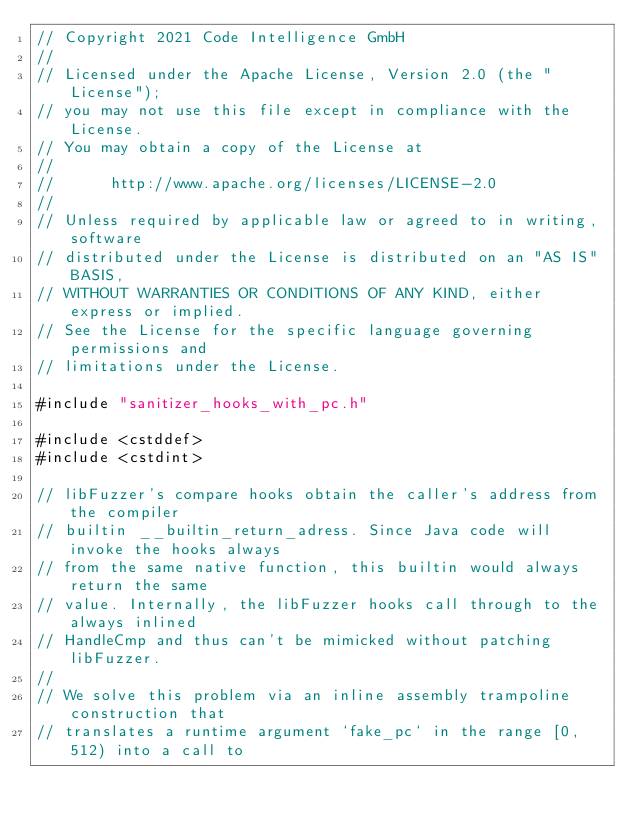Convert code to text. <code><loc_0><loc_0><loc_500><loc_500><_C++_>// Copyright 2021 Code Intelligence GmbH
//
// Licensed under the Apache License, Version 2.0 (the "License");
// you may not use this file except in compliance with the License.
// You may obtain a copy of the License at
//
//      http://www.apache.org/licenses/LICENSE-2.0
//
// Unless required by applicable law or agreed to in writing, software
// distributed under the License is distributed on an "AS IS" BASIS,
// WITHOUT WARRANTIES OR CONDITIONS OF ANY KIND, either express or implied.
// See the License for the specific language governing permissions and
// limitations under the License.

#include "sanitizer_hooks_with_pc.h"

#include <cstddef>
#include <cstdint>

// libFuzzer's compare hooks obtain the caller's address from the compiler
// builtin __builtin_return_adress. Since Java code will invoke the hooks always
// from the same native function, this builtin would always return the same
// value. Internally, the libFuzzer hooks call through to the always inlined
// HandleCmp and thus can't be mimicked without patching libFuzzer.
//
// We solve this problem via an inline assembly trampoline construction that
// translates a runtime argument `fake_pc` in the range [0, 512) into a call to</code> 